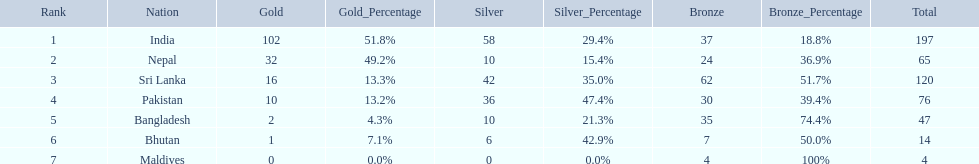What is the difference in total number of medals between india and nepal? 132. 